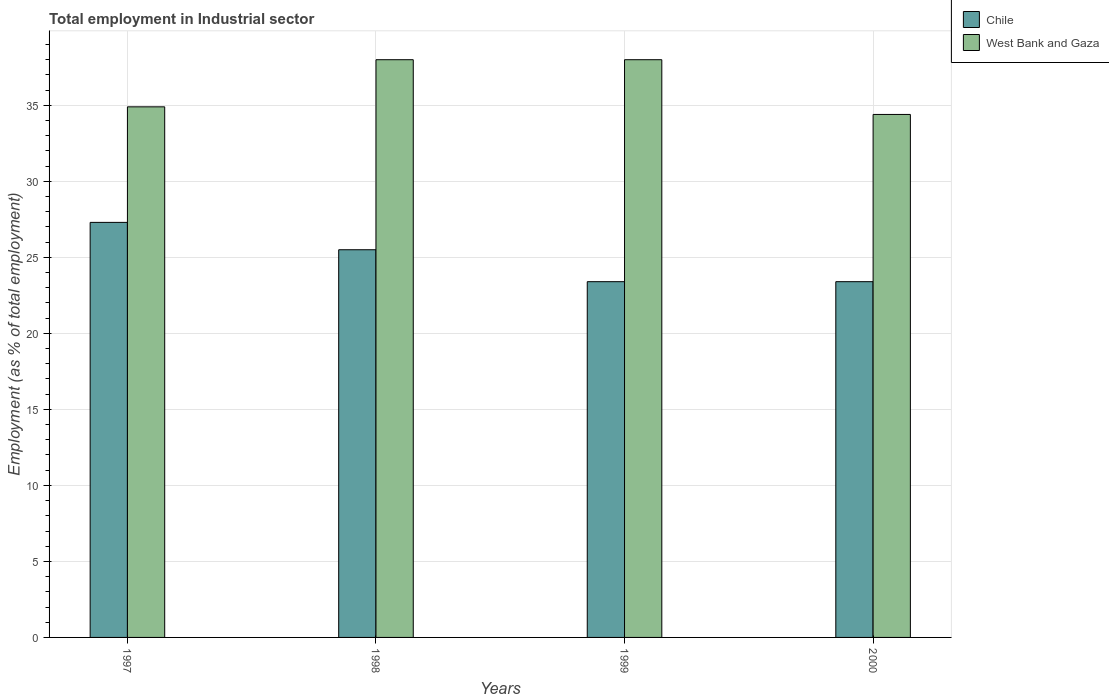Are the number of bars per tick equal to the number of legend labels?
Keep it short and to the point. Yes. In how many cases, is the number of bars for a given year not equal to the number of legend labels?
Your answer should be very brief. 0. What is the employment in industrial sector in West Bank and Gaza in 1997?
Your answer should be compact. 34.9. Across all years, what is the maximum employment in industrial sector in Chile?
Give a very brief answer. 27.3. Across all years, what is the minimum employment in industrial sector in West Bank and Gaza?
Provide a short and direct response. 34.4. In which year was the employment in industrial sector in West Bank and Gaza maximum?
Give a very brief answer. 1998. What is the total employment in industrial sector in Chile in the graph?
Offer a terse response. 99.6. What is the difference between the employment in industrial sector in West Bank and Gaza in 1998 and that in 1999?
Your response must be concise. 0. What is the difference between the employment in industrial sector in West Bank and Gaza in 2000 and the employment in industrial sector in Chile in 1998?
Your answer should be very brief. 8.9. What is the average employment in industrial sector in West Bank and Gaza per year?
Keep it short and to the point. 36.33. In the year 2000, what is the difference between the employment in industrial sector in Chile and employment in industrial sector in West Bank and Gaza?
Keep it short and to the point. -11. In how many years, is the employment in industrial sector in Chile greater than 25 %?
Ensure brevity in your answer.  2. What is the ratio of the employment in industrial sector in West Bank and Gaza in 1997 to that in 2000?
Your response must be concise. 1.01. Is the difference between the employment in industrial sector in Chile in 1998 and 2000 greater than the difference between the employment in industrial sector in West Bank and Gaza in 1998 and 2000?
Provide a succinct answer. No. What is the difference between the highest and the second highest employment in industrial sector in Chile?
Ensure brevity in your answer.  1.8. What is the difference between the highest and the lowest employment in industrial sector in West Bank and Gaza?
Provide a short and direct response. 3.6. Is the sum of the employment in industrial sector in Chile in 1997 and 1999 greater than the maximum employment in industrial sector in West Bank and Gaza across all years?
Offer a very short reply. Yes. What does the 1st bar from the right in 1999 represents?
Give a very brief answer. West Bank and Gaza. Are all the bars in the graph horizontal?
Your answer should be very brief. No. What is the difference between two consecutive major ticks on the Y-axis?
Provide a short and direct response. 5. Does the graph contain any zero values?
Give a very brief answer. No. Where does the legend appear in the graph?
Your response must be concise. Top right. How many legend labels are there?
Give a very brief answer. 2. What is the title of the graph?
Your answer should be compact. Total employment in Industrial sector. What is the label or title of the Y-axis?
Offer a very short reply. Employment (as % of total employment). What is the Employment (as % of total employment) of Chile in 1997?
Keep it short and to the point. 27.3. What is the Employment (as % of total employment) of West Bank and Gaza in 1997?
Provide a succinct answer. 34.9. What is the Employment (as % of total employment) of Chile in 1999?
Your answer should be very brief. 23.4. What is the Employment (as % of total employment) of West Bank and Gaza in 1999?
Your answer should be compact. 38. What is the Employment (as % of total employment) in Chile in 2000?
Ensure brevity in your answer.  23.4. What is the Employment (as % of total employment) of West Bank and Gaza in 2000?
Offer a terse response. 34.4. Across all years, what is the maximum Employment (as % of total employment) of Chile?
Keep it short and to the point. 27.3. Across all years, what is the minimum Employment (as % of total employment) in Chile?
Ensure brevity in your answer.  23.4. Across all years, what is the minimum Employment (as % of total employment) of West Bank and Gaza?
Keep it short and to the point. 34.4. What is the total Employment (as % of total employment) of Chile in the graph?
Offer a very short reply. 99.6. What is the total Employment (as % of total employment) of West Bank and Gaza in the graph?
Provide a short and direct response. 145.3. What is the difference between the Employment (as % of total employment) of Chile in 1997 and that in 1998?
Your response must be concise. 1.8. What is the difference between the Employment (as % of total employment) of Chile in 1997 and that in 1999?
Your answer should be compact. 3.9. What is the difference between the Employment (as % of total employment) of Chile in 1997 and that in 2000?
Provide a short and direct response. 3.9. What is the difference between the Employment (as % of total employment) of West Bank and Gaza in 1998 and that in 1999?
Provide a short and direct response. 0. What is the difference between the Employment (as % of total employment) in Chile in 1998 and that in 2000?
Offer a very short reply. 2.1. What is the difference between the Employment (as % of total employment) in West Bank and Gaza in 1998 and that in 2000?
Provide a short and direct response. 3.6. What is the difference between the Employment (as % of total employment) in Chile in 1999 and that in 2000?
Your answer should be compact. 0. What is the difference between the Employment (as % of total employment) in West Bank and Gaza in 1999 and that in 2000?
Ensure brevity in your answer.  3.6. What is the difference between the Employment (as % of total employment) of Chile in 1997 and the Employment (as % of total employment) of West Bank and Gaza in 2000?
Offer a terse response. -7.1. What is the difference between the Employment (as % of total employment) in Chile in 1999 and the Employment (as % of total employment) in West Bank and Gaza in 2000?
Offer a very short reply. -11. What is the average Employment (as % of total employment) of Chile per year?
Give a very brief answer. 24.9. What is the average Employment (as % of total employment) in West Bank and Gaza per year?
Make the answer very short. 36.33. In the year 1997, what is the difference between the Employment (as % of total employment) of Chile and Employment (as % of total employment) of West Bank and Gaza?
Offer a very short reply. -7.6. In the year 1999, what is the difference between the Employment (as % of total employment) of Chile and Employment (as % of total employment) of West Bank and Gaza?
Provide a short and direct response. -14.6. In the year 2000, what is the difference between the Employment (as % of total employment) in Chile and Employment (as % of total employment) in West Bank and Gaza?
Your answer should be compact. -11. What is the ratio of the Employment (as % of total employment) of Chile in 1997 to that in 1998?
Give a very brief answer. 1.07. What is the ratio of the Employment (as % of total employment) in West Bank and Gaza in 1997 to that in 1998?
Make the answer very short. 0.92. What is the ratio of the Employment (as % of total employment) of Chile in 1997 to that in 1999?
Provide a succinct answer. 1.17. What is the ratio of the Employment (as % of total employment) in West Bank and Gaza in 1997 to that in 1999?
Keep it short and to the point. 0.92. What is the ratio of the Employment (as % of total employment) in Chile in 1997 to that in 2000?
Ensure brevity in your answer.  1.17. What is the ratio of the Employment (as % of total employment) of West Bank and Gaza in 1997 to that in 2000?
Offer a very short reply. 1.01. What is the ratio of the Employment (as % of total employment) in Chile in 1998 to that in 1999?
Keep it short and to the point. 1.09. What is the ratio of the Employment (as % of total employment) of West Bank and Gaza in 1998 to that in 1999?
Keep it short and to the point. 1. What is the ratio of the Employment (as % of total employment) of Chile in 1998 to that in 2000?
Offer a very short reply. 1.09. What is the ratio of the Employment (as % of total employment) in West Bank and Gaza in 1998 to that in 2000?
Your answer should be compact. 1.1. What is the ratio of the Employment (as % of total employment) in West Bank and Gaza in 1999 to that in 2000?
Your response must be concise. 1.1. What is the difference between the highest and the second highest Employment (as % of total employment) of Chile?
Your answer should be very brief. 1.8. 